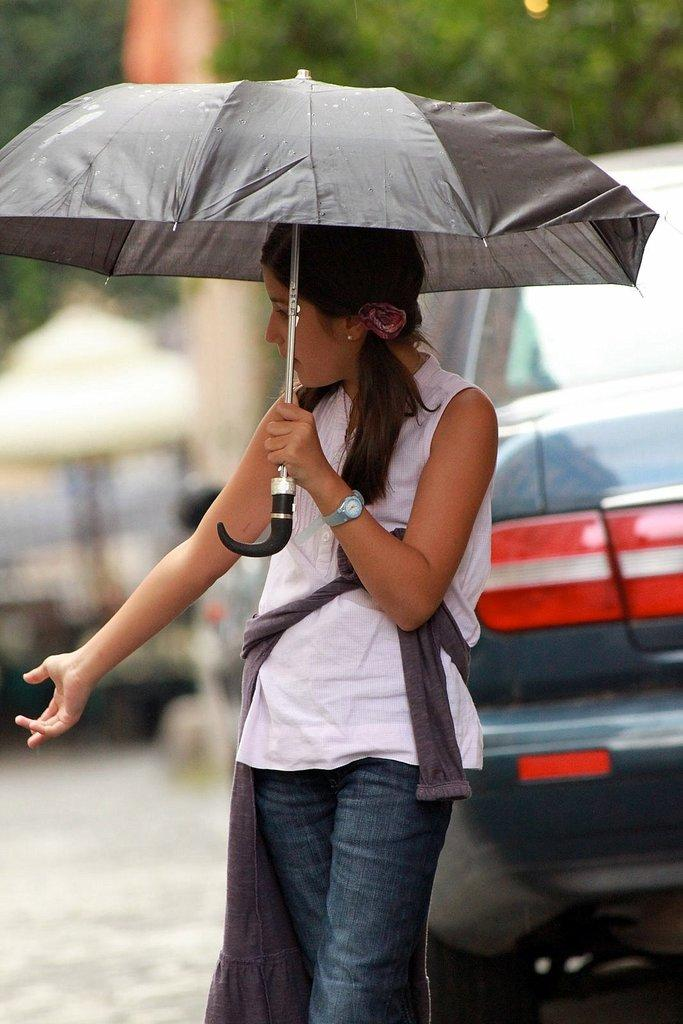Who is the main subject in the image? There is a lady in the image. What is the lady doing in the image? The lady is standing in the image. What object is the lady holding? The lady is holding an umbrella. What can be seen behind the lady in the image? There is a car behind the lady. What type of natural scenery is visible in the background of the image? There are trees in the background of the image. What type of chin can be seen on the lady in the image? There is no chin visible in the image, as it is a photograph of a lady from a distance and does not show her facial features. 